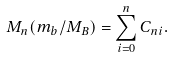Convert formula to latex. <formula><loc_0><loc_0><loc_500><loc_500>M _ { n } ( m _ { b } / M _ { B } ) = \sum _ { i = 0 } ^ { n } C _ { n i } .</formula> 